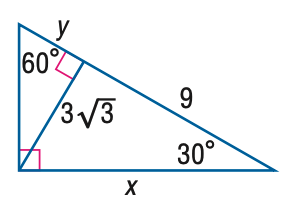Answer the mathemtical geometry problem and directly provide the correct option letter.
Question: Find x.
Choices: A: 3 \sqrt { 6 } B: 9 C: 6 \sqrt { 3 } D: 18 C 